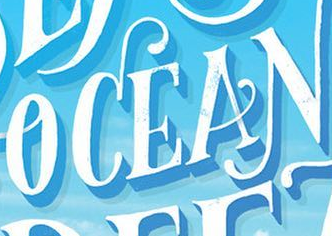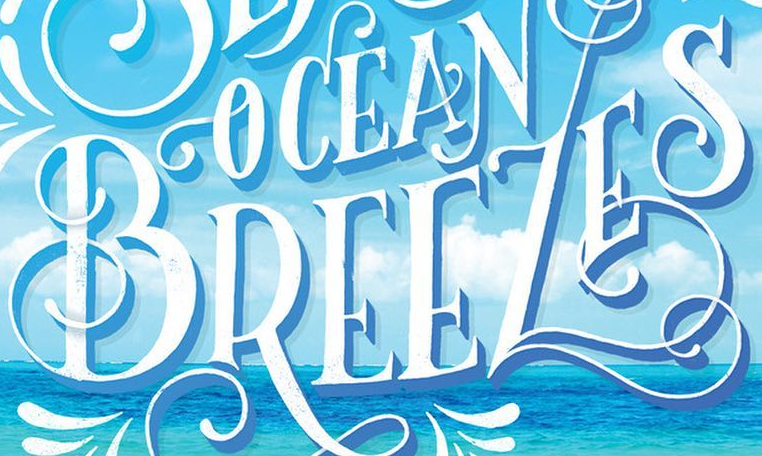Transcribe the words shown in these images in order, separated by a semicolon. OCEAN; BREEZES 